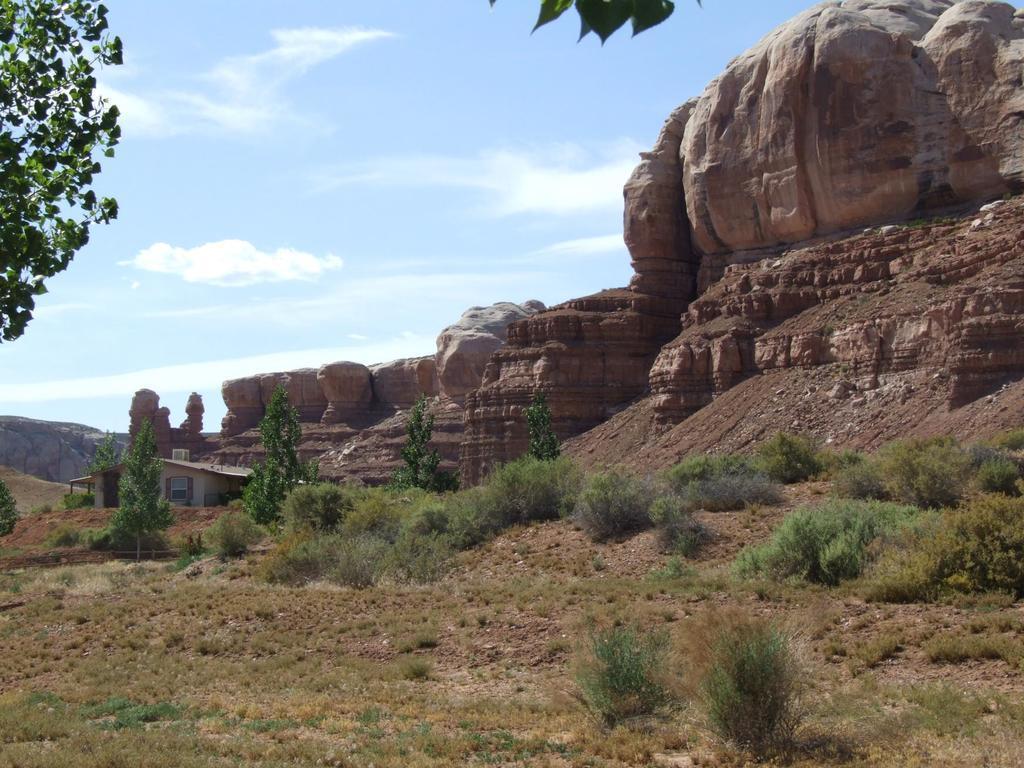Describe this image in one or two sentences. In the image we can see some trees and plants and hills and house. Behind the hill there are some clouds and sky. 